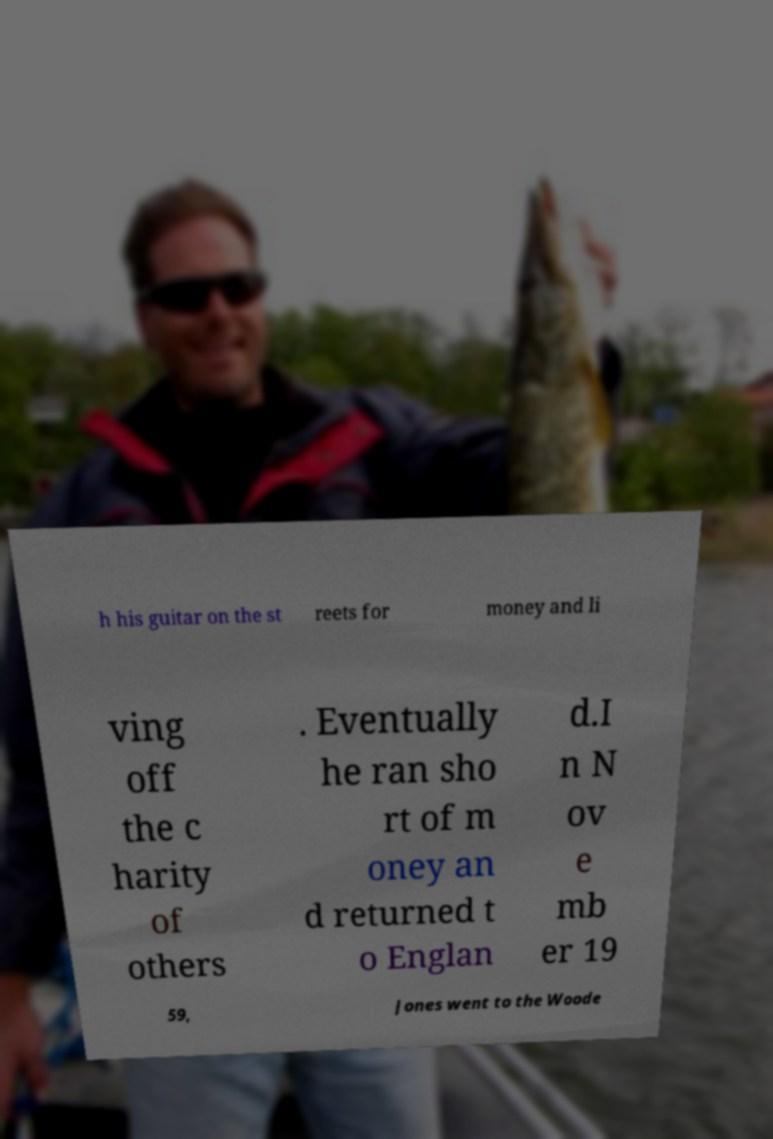For documentation purposes, I need the text within this image transcribed. Could you provide that? h his guitar on the st reets for money and li ving off the c harity of others . Eventually he ran sho rt of m oney an d returned t o Englan d.I n N ov e mb er 19 59, Jones went to the Woode 